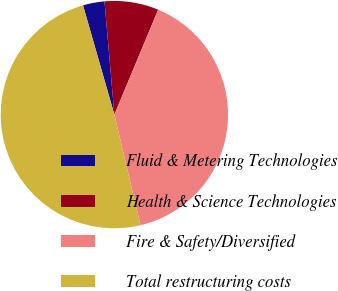Convert chart to OTSL. <chart><loc_0><loc_0><loc_500><loc_500><pie_chart><fcel>Fluid & Metering Technologies<fcel>Health & Science Technologies<fcel>Fire & Safety/Diversified<fcel>Total restructuring costs<nl><fcel>3.06%<fcel>7.68%<fcel>40.01%<fcel>49.25%<nl></chart> 